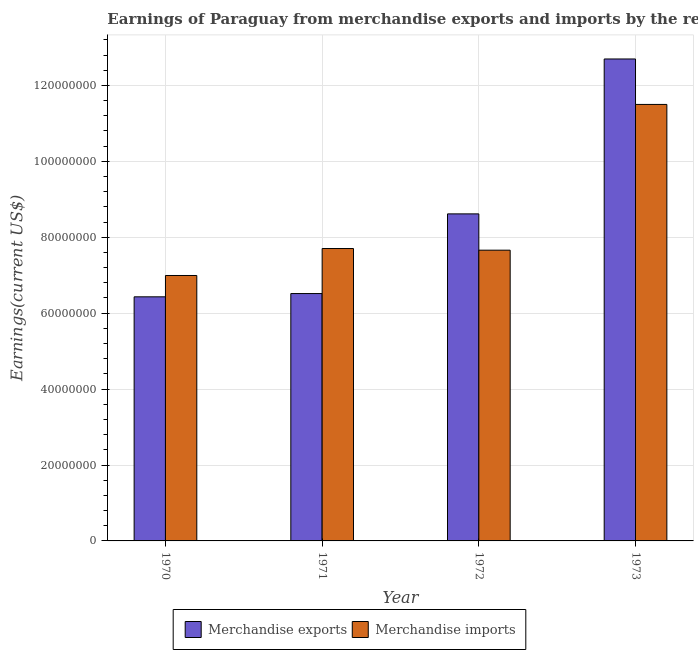How many groups of bars are there?
Your answer should be compact. 4. How many bars are there on the 1st tick from the left?
Keep it short and to the point. 2. What is the label of the 3rd group of bars from the left?
Keep it short and to the point. 1972. In how many cases, is the number of bars for a given year not equal to the number of legend labels?
Give a very brief answer. 0. What is the earnings from merchandise imports in 1972?
Keep it short and to the point. 7.66e+07. Across all years, what is the maximum earnings from merchandise imports?
Ensure brevity in your answer.  1.15e+08. Across all years, what is the minimum earnings from merchandise imports?
Make the answer very short. 6.99e+07. What is the total earnings from merchandise exports in the graph?
Your answer should be very brief. 3.43e+08. What is the difference between the earnings from merchandise imports in 1972 and that in 1973?
Your answer should be very brief. -3.84e+07. What is the difference between the earnings from merchandise imports in 1973 and the earnings from merchandise exports in 1970?
Keep it short and to the point. 4.51e+07. What is the average earnings from merchandise imports per year?
Ensure brevity in your answer.  8.46e+07. In how many years, is the earnings from merchandise imports greater than 92000000 US$?
Your response must be concise. 1. What is the ratio of the earnings from merchandise imports in 1970 to that in 1971?
Your response must be concise. 0.91. Is the earnings from merchandise imports in 1971 less than that in 1973?
Ensure brevity in your answer.  Yes. What is the difference between the highest and the second highest earnings from merchandise exports?
Give a very brief answer. 4.08e+07. What is the difference between the highest and the lowest earnings from merchandise imports?
Your answer should be compact. 4.51e+07. What does the 2nd bar from the right in 1973 represents?
Your answer should be very brief. Merchandise exports. How many bars are there?
Provide a short and direct response. 8. How many years are there in the graph?
Your answer should be very brief. 4. What is the difference between two consecutive major ticks on the Y-axis?
Give a very brief answer. 2.00e+07. Are the values on the major ticks of Y-axis written in scientific E-notation?
Provide a succinct answer. No. Does the graph contain grids?
Offer a terse response. Yes. Where does the legend appear in the graph?
Make the answer very short. Bottom center. How many legend labels are there?
Provide a succinct answer. 2. What is the title of the graph?
Keep it short and to the point. Earnings of Paraguay from merchandise exports and imports by the reporting economy. What is the label or title of the X-axis?
Offer a terse response. Year. What is the label or title of the Y-axis?
Ensure brevity in your answer.  Earnings(current US$). What is the Earnings(current US$) in Merchandise exports in 1970?
Ensure brevity in your answer.  6.43e+07. What is the Earnings(current US$) in Merchandise imports in 1970?
Keep it short and to the point. 6.99e+07. What is the Earnings(current US$) in Merchandise exports in 1971?
Make the answer very short. 6.52e+07. What is the Earnings(current US$) of Merchandise imports in 1971?
Keep it short and to the point. 7.70e+07. What is the Earnings(current US$) in Merchandise exports in 1972?
Offer a very short reply. 8.62e+07. What is the Earnings(current US$) of Merchandise imports in 1972?
Provide a short and direct response. 7.66e+07. What is the Earnings(current US$) of Merchandise exports in 1973?
Offer a terse response. 1.27e+08. What is the Earnings(current US$) of Merchandise imports in 1973?
Provide a short and direct response. 1.15e+08. Across all years, what is the maximum Earnings(current US$) in Merchandise exports?
Make the answer very short. 1.27e+08. Across all years, what is the maximum Earnings(current US$) in Merchandise imports?
Provide a succinct answer. 1.15e+08. Across all years, what is the minimum Earnings(current US$) of Merchandise exports?
Provide a succinct answer. 6.43e+07. Across all years, what is the minimum Earnings(current US$) in Merchandise imports?
Your answer should be compact. 6.99e+07. What is the total Earnings(current US$) of Merchandise exports in the graph?
Your response must be concise. 3.43e+08. What is the total Earnings(current US$) of Merchandise imports in the graph?
Give a very brief answer. 3.39e+08. What is the difference between the Earnings(current US$) of Merchandise exports in 1970 and that in 1971?
Provide a short and direct response. -8.61e+05. What is the difference between the Earnings(current US$) of Merchandise imports in 1970 and that in 1971?
Your response must be concise. -7.10e+06. What is the difference between the Earnings(current US$) of Merchandise exports in 1970 and that in 1972?
Provide a short and direct response. -2.19e+07. What is the difference between the Earnings(current US$) of Merchandise imports in 1970 and that in 1972?
Offer a terse response. -6.67e+06. What is the difference between the Earnings(current US$) in Merchandise exports in 1970 and that in 1973?
Give a very brief answer. -6.27e+07. What is the difference between the Earnings(current US$) in Merchandise imports in 1970 and that in 1973?
Offer a very short reply. -4.51e+07. What is the difference between the Earnings(current US$) of Merchandise exports in 1971 and that in 1972?
Offer a terse response. -2.10e+07. What is the difference between the Earnings(current US$) of Merchandise imports in 1971 and that in 1972?
Keep it short and to the point. 4.37e+05. What is the difference between the Earnings(current US$) of Merchandise exports in 1971 and that in 1973?
Your answer should be compact. -6.18e+07. What is the difference between the Earnings(current US$) of Merchandise imports in 1971 and that in 1973?
Ensure brevity in your answer.  -3.80e+07. What is the difference between the Earnings(current US$) in Merchandise exports in 1972 and that in 1973?
Your answer should be very brief. -4.08e+07. What is the difference between the Earnings(current US$) in Merchandise imports in 1972 and that in 1973?
Provide a succinct answer. -3.84e+07. What is the difference between the Earnings(current US$) of Merchandise exports in 1970 and the Earnings(current US$) of Merchandise imports in 1971?
Provide a short and direct response. -1.27e+07. What is the difference between the Earnings(current US$) of Merchandise exports in 1970 and the Earnings(current US$) of Merchandise imports in 1972?
Provide a succinct answer. -1.23e+07. What is the difference between the Earnings(current US$) in Merchandise exports in 1970 and the Earnings(current US$) in Merchandise imports in 1973?
Offer a very short reply. -5.07e+07. What is the difference between the Earnings(current US$) in Merchandise exports in 1971 and the Earnings(current US$) in Merchandise imports in 1972?
Make the answer very short. -1.14e+07. What is the difference between the Earnings(current US$) of Merchandise exports in 1971 and the Earnings(current US$) of Merchandise imports in 1973?
Make the answer very short. -4.98e+07. What is the difference between the Earnings(current US$) of Merchandise exports in 1972 and the Earnings(current US$) of Merchandise imports in 1973?
Your answer should be very brief. -2.88e+07. What is the average Earnings(current US$) in Merchandise exports per year?
Provide a short and direct response. 8.56e+07. What is the average Earnings(current US$) of Merchandise imports per year?
Your response must be concise. 8.46e+07. In the year 1970, what is the difference between the Earnings(current US$) of Merchandise exports and Earnings(current US$) of Merchandise imports?
Offer a terse response. -5.62e+06. In the year 1971, what is the difference between the Earnings(current US$) of Merchandise exports and Earnings(current US$) of Merchandise imports?
Your response must be concise. -1.19e+07. In the year 1972, what is the difference between the Earnings(current US$) of Merchandise exports and Earnings(current US$) of Merchandise imports?
Your response must be concise. 9.56e+06. In the year 1973, what is the difference between the Earnings(current US$) of Merchandise exports and Earnings(current US$) of Merchandise imports?
Your response must be concise. 1.20e+07. What is the ratio of the Earnings(current US$) of Merchandise imports in 1970 to that in 1971?
Ensure brevity in your answer.  0.91. What is the ratio of the Earnings(current US$) of Merchandise exports in 1970 to that in 1972?
Offer a terse response. 0.75. What is the ratio of the Earnings(current US$) of Merchandise imports in 1970 to that in 1972?
Provide a short and direct response. 0.91. What is the ratio of the Earnings(current US$) in Merchandise exports in 1970 to that in 1973?
Offer a very short reply. 0.51. What is the ratio of the Earnings(current US$) in Merchandise imports in 1970 to that in 1973?
Give a very brief answer. 0.61. What is the ratio of the Earnings(current US$) in Merchandise exports in 1971 to that in 1972?
Give a very brief answer. 0.76. What is the ratio of the Earnings(current US$) of Merchandise exports in 1971 to that in 1973?
Your answer should be very brief. 0.51. What is the ratio of the Earnings(current US$) in Merchandise imports in 1971 to that in 1973?
Offer a very short reply. 0.67. What is the ratio of the Earnings(current US$) in Merchandise exports in 1972 to that in 1973?
Provide a succinct answer. 0.68. What is the ratio of the Earnings(current US$) of Merchandise imports in 1972 to that in 1973?
Your response must be concise. 0.67. What is the difference between the highest and the second highest Earnings(current US$) in Merchandise exports?
Ensure brevity in your answer.  4.08e+07. What is the difference between the highest and the second highest Earnings(current US$) in Merchandise imports?
Provide a succinct answer. 3.80e+07. What is the difference between the highest and the lowest Earnings(current US$) in Merchandise exports?
Provide a short and direct response. 6.27e+07. What is the difference between the highest and the lowest Earnings(current US$) of Merchandise imports?
Give a very brief answer. 4.51e+07. 